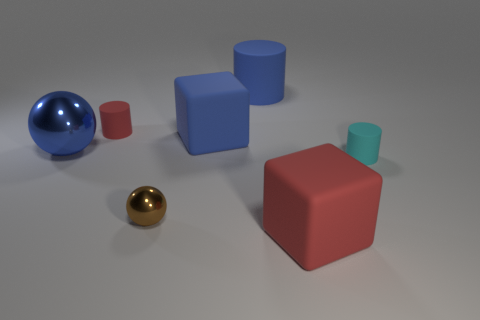Is the color of the large shiny sphere the same as the large rubber cylinder?
Your response must be concise. Yes. How many big metal spheres are there?
Your answer should be very brief. 1. What number of cylinders are either small red matte things or large rubber objects?
Ensure brevity in your answer.  2. How many blue metal things are on the left side of the large blue thing that is to the left of the brown metallic object?
Your response must be concise. 0. Do the small red object and the brown object have the same material?
Make the answer very short. No. Is there a small blue cylinder made of the same material as the small red cylinder?
Give a very brief answer. No. What color is the small rubber thing that is on the right side of the large blue rubber object in front of the red thing behind the small cyan matte object?
Keep it short and to the point. Cyan. What number of purple things are either big spheres or tiny matte cylinders?
Offer a terse response. 0. How many tiny cyan things have the same shape as the big red rubber object?
Give a very brief answer. 0. The blue metallic object that is the same size as the blue cylinder is what shape?
Offer a very short reply. Sphere. 